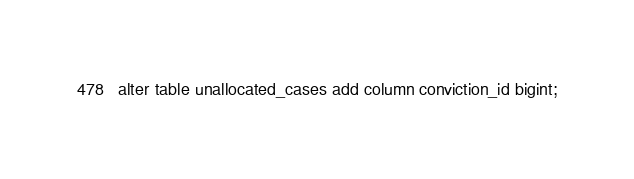Convert code to text. <code><loc_0><loc_0><loc_500><loc_500><_SQL_>alter table unallocated_cases add column conviction_id bigint;</code> 